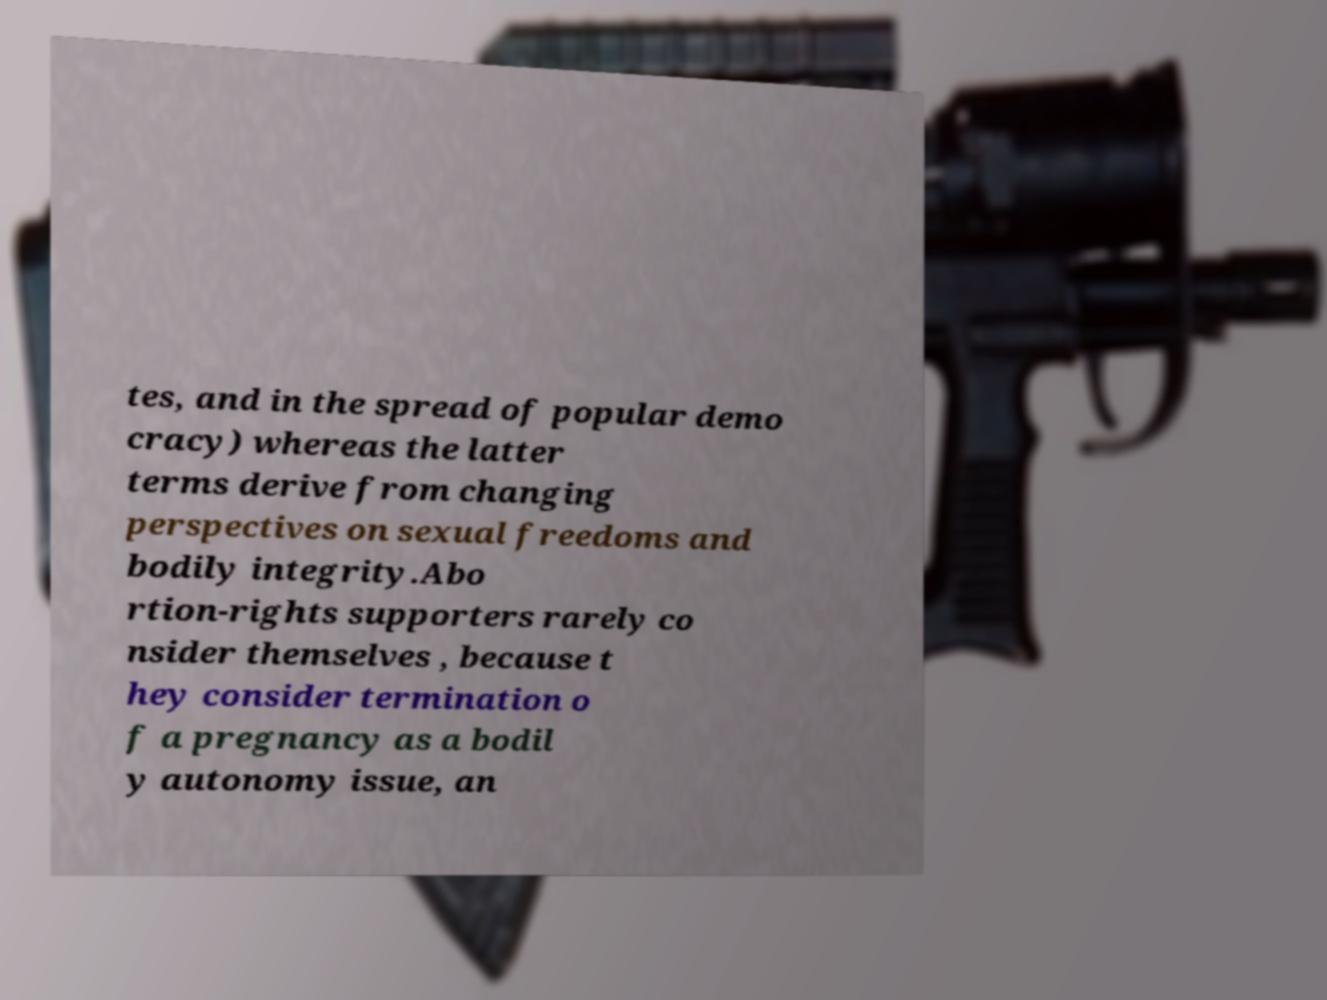Please identify and transcribe the text found in this image. tes, and in the spread of popular demo cracy) whereas the latter terms derive from changing perspectives on sexual freedoms and bodily integrity.Abo rtion-rights supporters rarely co nsider themselves , because t hey consider termination o f a pregnancy as a bodil y autonomy issue, an 